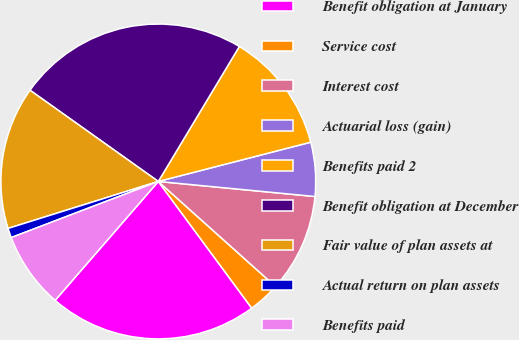<chart> <loc_0><loc_0><loc_500><loc_500><pie_chart><fcel>Benefit obligation at January<fcel>Service cost<fcel>Interest cost<fcel>Actuarial loss (gain)<fcel>Benefits paid 2<fcel>Benefit obligation at December<fcel>Fair value of plan assets at<fcel>Actual return on plan assets<fcel>Benefits paid<nl><fcel>21.49%<fcel>3.26%<fcel>10.1%<fcel>5.54%<fcel>12.38%<fcel>23.77%<fcel>14.66%<fcel>0.98%<fcel>7.82%<nl></chart> 